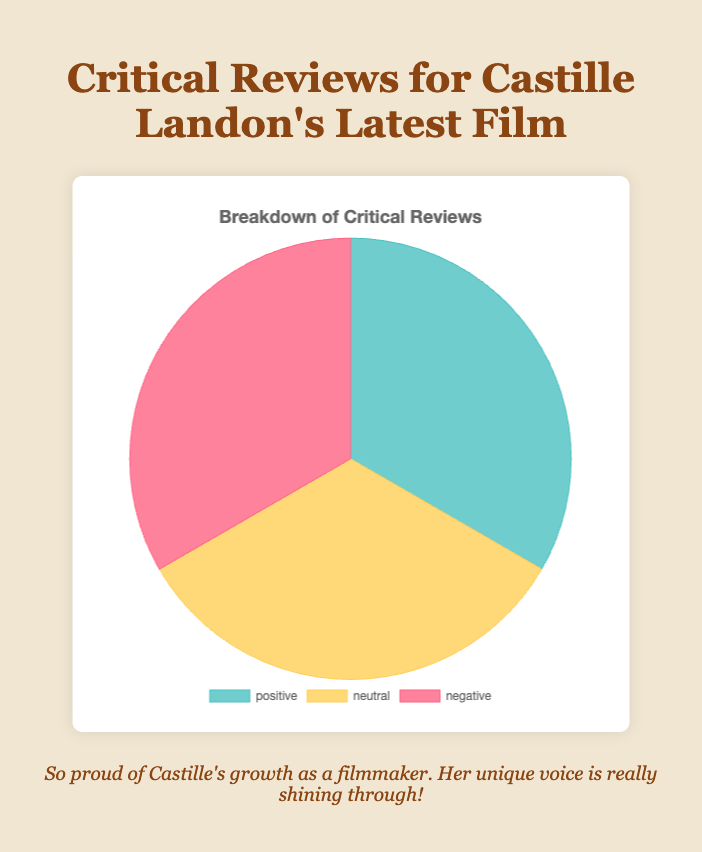How many total reviews were there for Castille Landon's latest film? By looking at the pie chart, count the number of segments and add up their values: 3 positive reviews, 3 neutral reviews, and 3 negative reviews. So, 3 + 3 + 3 = 9.
Answer: 9 Which type of review had the highest count? In the pie chart, all segments representing positive, neutral, and negative reviews are equal in size, indicating that they all have the same frequency. There are 3 reviews each for positive, neutral, and negative.
Answer: Equal for all Which type of review had the lowest count? By observing the pie chart, all segments appear to be of equal size, indicating that there are an equal number of positive, neutral, and negative reviews. They all appear three times.
Answer: Equal for all How many positive reviews are there compared to negative ones? Check the pie chart for the segments labeled "positive" and "negative." Both segments are of equal size, each representing three reviews. Therefore, there are an equal number of positive and negative reviews.
Answer: Equal Are there more neutral reviews or positive reviews? Examine the pie chart segments labeled "neutral" and "positive." Both segments have the same size, each representing 3 reviews. Thus, there are an equal number of neutral and positive reviews.
Answer: Equal What proportion of reviews are positive? From the pie chart, there are 3 positive reviews out of a total of 9 reviews. The proportion is calculated as 3/9 = 1/3 or approximately 33.3%.
Answer: Approximately 33.3% What proportion of reviews are either positive or neutral? Add the number of positive reviews (3) to the number of neutral reviews (3) to get 6. The total number of reviews is 9. The proportion is 6/9 = 2/3 or approximately 66.7%.
Answer: Approximately 66.7% If another positive review is added, what would be the new proportion of positive reviews? Currently, there are 3 positive reviews out of 9 total reviews. Adding one more positive review makes it 4 positive reviews out of 10 total reviews. The new proportion is 4/10 = 0.4 or 40%.
Answer: 40% How does the count of negative reviews compare with the combined count of positive and neutral reviews? From the pie chart, there are 3 negative reviews. The combined count of positive (3) and neutral (3) reviews is 3 + 3 = 6. So, negative reviews are half the combined count of positive and neutral reviews.
Answer: Half 